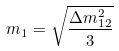Convert formula to latex. <formula><loc_0><loc_0><loc_500><loc_500>m _ { 1 } = \sqrt { \frac { \Delta m _ { 1 2 } ^ { 2 } } { 3 } }</formula> 